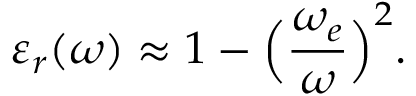<formula> <loc_0><loc_0><loc_500><loc_500>\varepsilon _ { r } ( \omega ) \approx 1 - \left ( \frac { \omega _ { e } } { \omega } \right ) ^ { 2 } .</formula> 